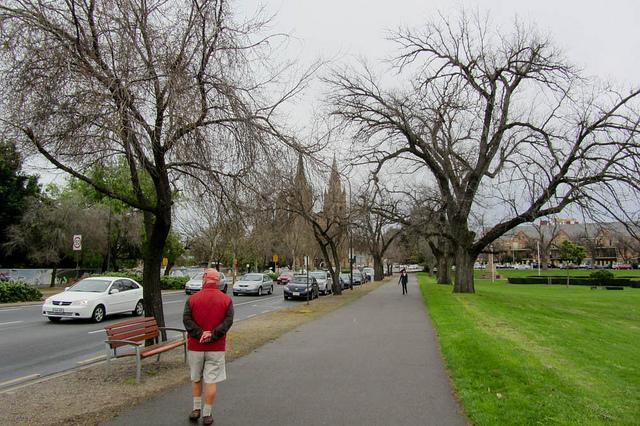What type trees are shown in the area nearest the red shirted walker? deciduous 